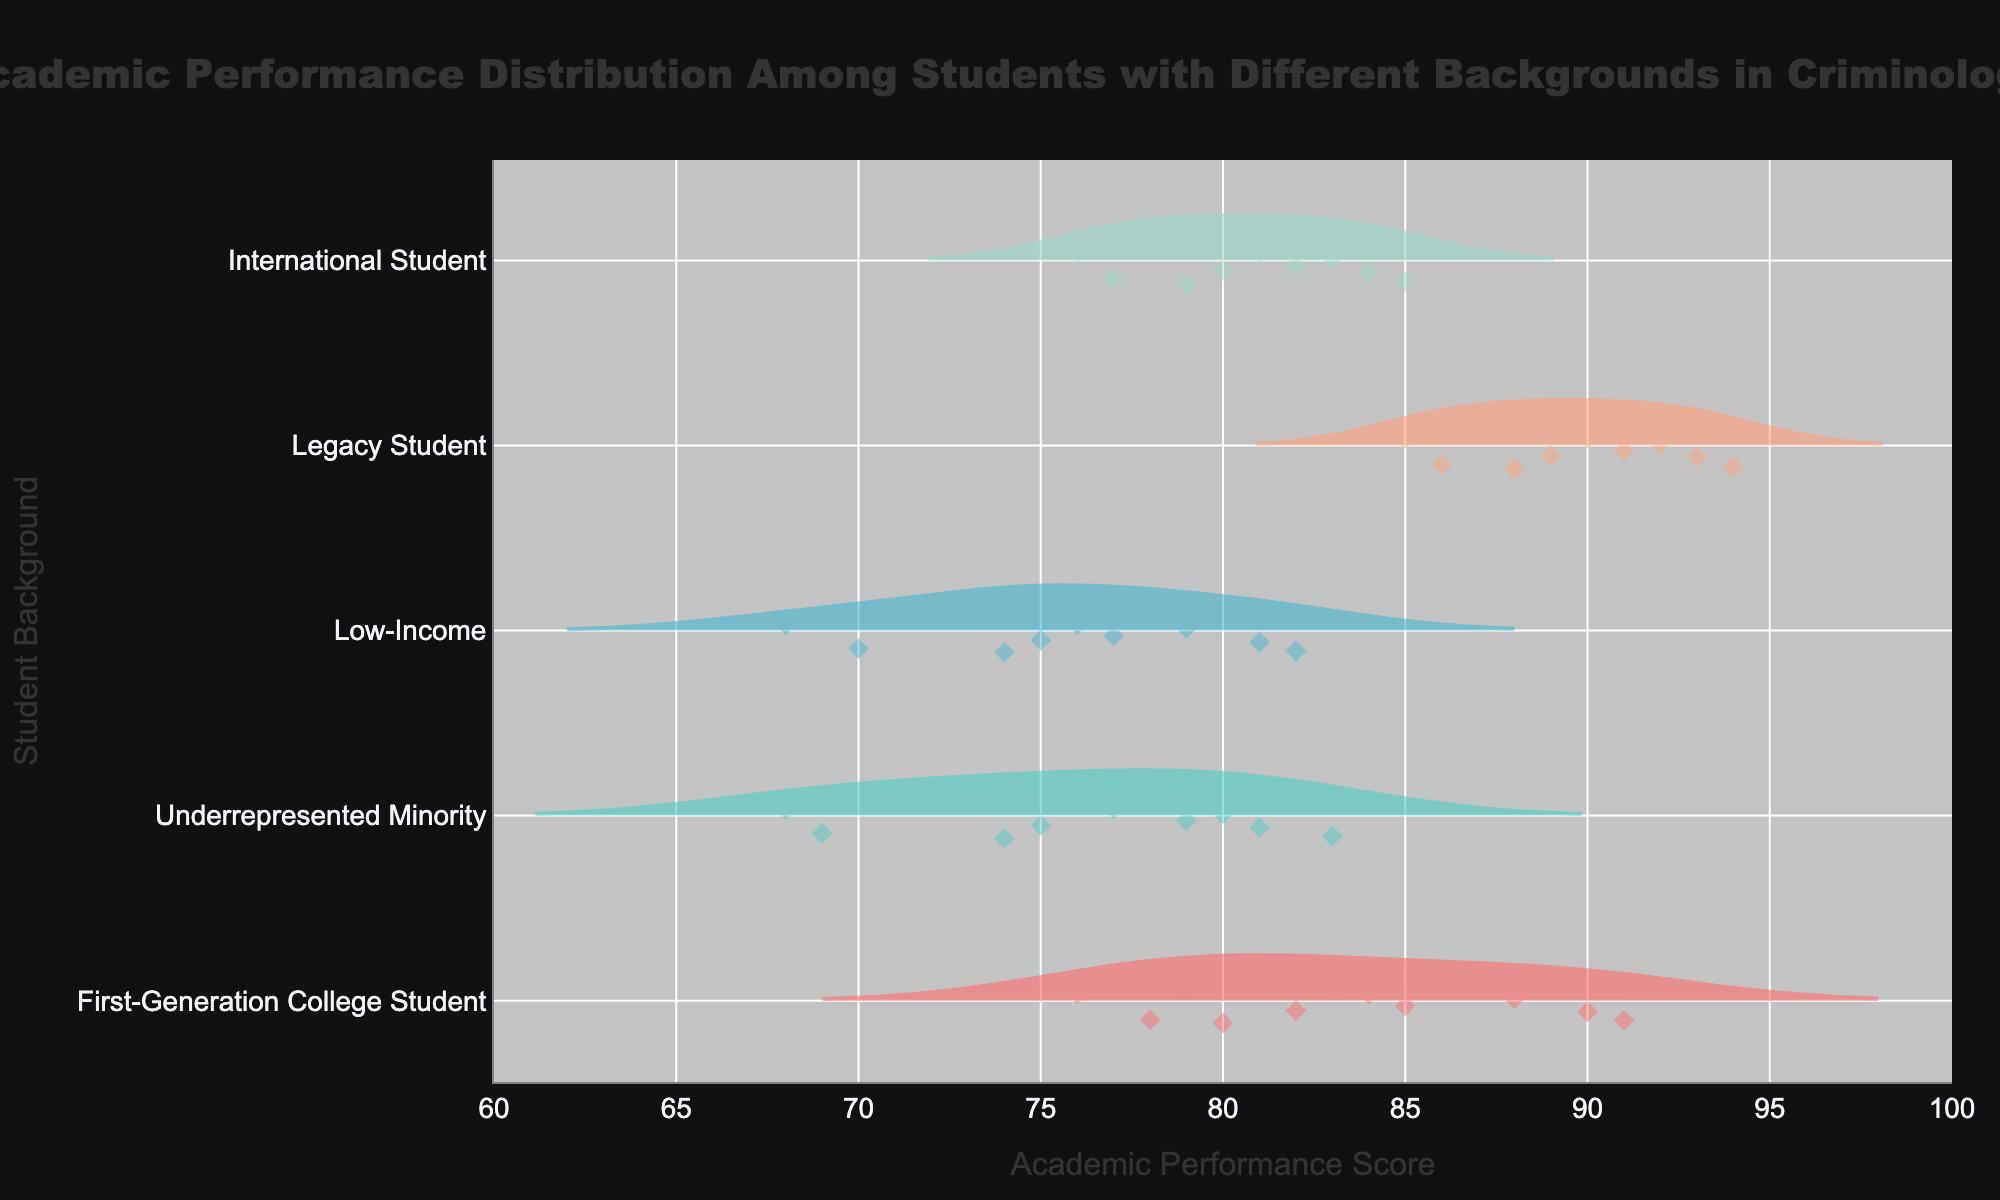What is the title of the figure? The title is located at the top of the figure, centered, and clearly states the subject of the data being visualized.
Answer: Academic Performance Distribution Among Students with Different Backgrounds in Criminology What is the range of academic performance scores displayed on the x-axis? The range is derived from the lowest to the highest tick marks on the x-axis, which are clearly labeled.
Answer: 60 to 100 Which student background has the highest mean academic performance score? By observing the mean lines displayed for each group, you can determine which one is positioned the furthest to the right on the x-axis.
Answer: Legacy Student How many data points are represented for First-Generation College Students? The number of points visible within the violin shape for the First-Generation College Student category can be counted.
Answer: 10 Which two student backgrounds have overlapping academic performance scores? By checking the overlapping areas of the violins for different groups, you can see which groups share similar ranges on the x-axis.
Answer: Low-Income and Underrepresented Minority What is the median academic performance score for International Students? The median is indicated by a line inside the boxplot within the violin for the International Student group.
Answer: 80 Which student background shows the widest distribution of academic performance scores? The width of the violins across the x-axis is used to judge the spread, indicating variability in scores.
Answer: Underrepresented Minority Do Legacy Students perform consistently higher than Low-Income students on average? Compare the central tendency indicators (mean lines) of the violins representing Legacy Students and Low-Income students.
Answer: Yes Which student background has the smallest range of academic performance scores? This can be evaluated by comparing the length of the violins on the x-axis for each group and identifying the shortest one.
Answer: Legacy Student How does the top performance of First-Generation College Students compare to that of International Students? By comparing the highest points in the violins of these two groups, you can see which has a higher top performance score.
Answer: First-Generation College Students are higher 